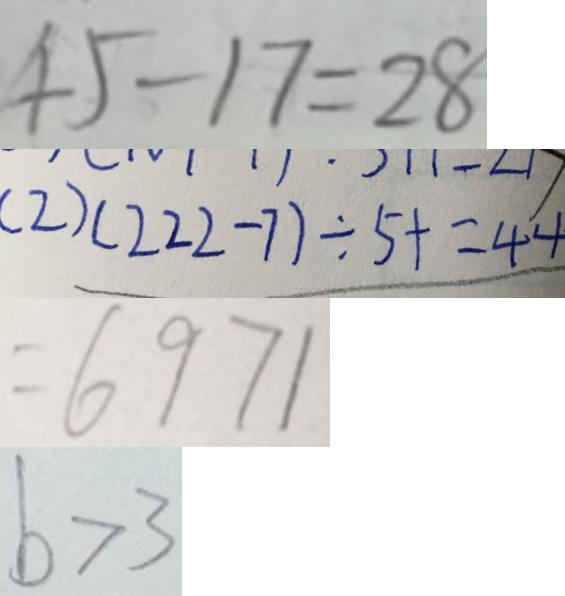Convert formula to latex. <formula><loc_0><loc_0><loc_500><loc_500>4 5 - 1 7 = 2 8 
 ( 2 ) ( 2 2 2 - 7 ) \div 5 + = 4 4 
 = 6 9 7 1 
 b > 3</formula> 